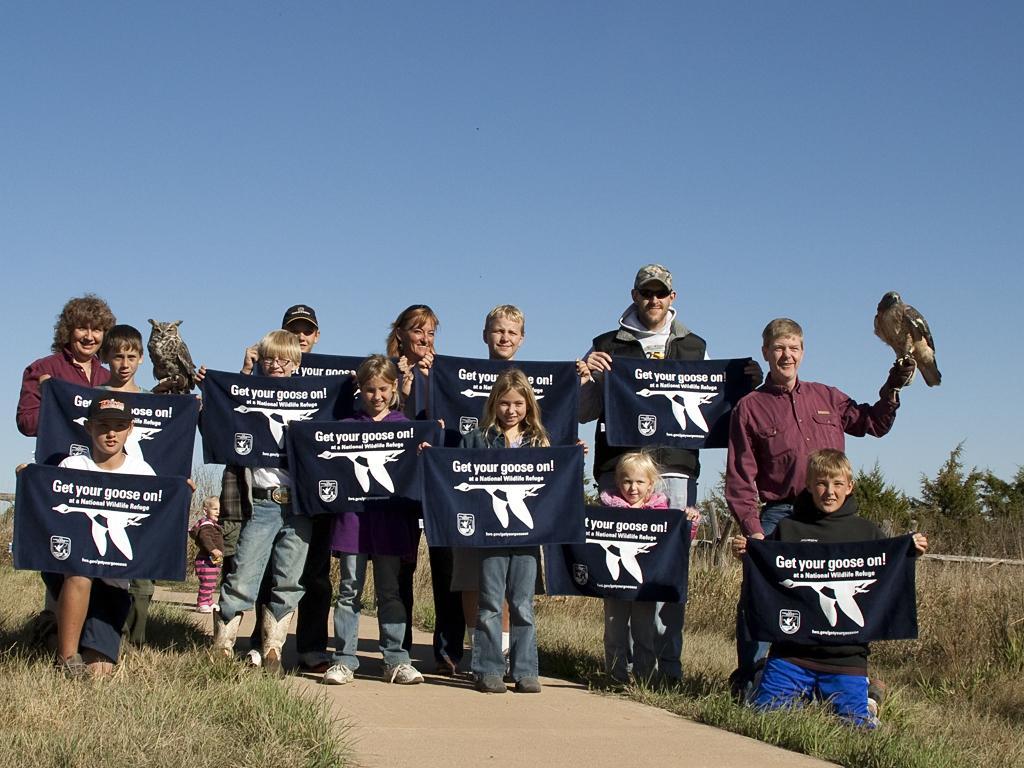In one or two sentences, can you explain what this image depicts? In the image we can see there are many children's standing, they are wearing clothes and shoes. They are holding a cloth in their hand, on the cloth there is a text. This is a path, grass, bird, trees and a pale blue sky. 